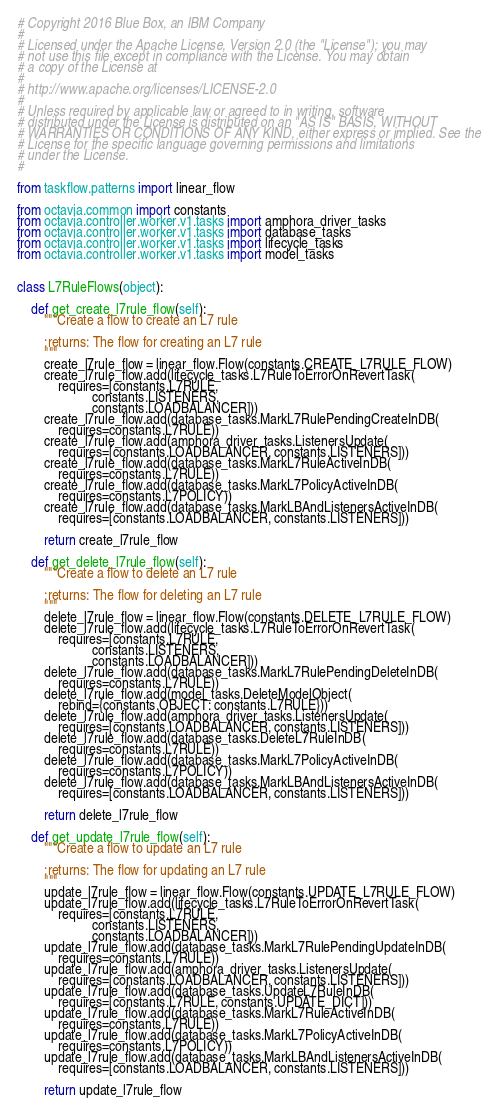Convert code to text. <code><loc_0><loc_0><loc_500><loc_500><_Python_># Copyright 2016 Blue Box, an IBM Company
#
# Licensed under the Apache License, Version 2.0 (the "License"); you may
# not use this file except in compliance with the License. You may obtain
# a copy of the License at
#
# http://www.apache.org/licenses/LICENSE-2.0
#
# Unless required by applicable law or agreed to in writing, software
# distributed under the License is distributed on an "AS IS" BASIS, WITHOUT
# WARRANTIES OR CONDITIONS OF ANY KIND, either express or implied. See the
# License for the specific language governing permissions and limitations
# under the License.
#

from taskflow.patterns import linear_flow

from octavia.common import constants
from octavia.controller.worker.v1.tasks import amphora_driver_tasks
from octavia.controller.worker.v1.tasks import database_tasks
from octavia.controller.worker.v1.tasks import lifecycle_tasks
from octavia.controller.worker.v1.tasks import model_tasks


class L7RuleFlows(object):

    def get_create_l7rule_flow(self):
        """Create a flow to create an L7 rule

        :returns: The flow for creating an L7 rule
        """
        create_l7rule_flow = linear_flow.Flow(constants.CREATE_L7RULE_FLOW)
        create_l7rule_flow.add(lifecycle_tasks.L7RuleToErrorOnRevertTask(
            requires=[constants.L7RULE,
                      constants.LISTENERS,
                      constants.LOADBALANCER]))
        create_l7rule_flow.add(database_tasks.MarkL7RulePendingCreateInDB(
            requires=constants.L7RULE))
        create_l7rule_flow.add(amphora_driver_tasks.ListenersUpdate(
            requires=[constants.LOADBALANCER, constants.LISTENERS]))
        create_l7rule_flow.add(database_tasks.MarkL7RuleActiveInDB(
            requires=constants.L7RULE))
        create_l7rule_flow.add(database_tasks.MarkL7PolicyActiveInDB(
            requires=constants.L7POLICY))
        create_l7rule_flow.add(database_tasks.MarkLBAndListenersActiveInDB(
            requires=[constants.LOADBALANCER, constants.LISTENERS]))

        return create_l7rule_flow

    def get_delete_l7rule_flow(self):
        """Create a flow to delete an L7 rule

        :returns: The flow for deleting an L7 rule
        """
        delete_l7rule_flow = linear_flow.Flow(constants.DELETE_L7RULE_FLOW)
        delete_l7rule_flow.add(lifecycle_tasks.L7RuleToErrorOnRevertTask(
            requires=[constants.L7RULE,
                      constants.LISTENERS,
                      constants.LOADBALANCER]))
        delete_l7rule_flow.add(database_tasks.MarkL7RulePendingDeleteInDB(
            requires=constants.L7RULE))
        delete_l7rule_flow.add(model_tasks.DeleteModelObject(
            rebind={constants.OBJECT: constants.L7RULE}))
        delete_l7rule_flow.add(amphora_driver_tasks.ListenersUpdate(
            requires=[constants.LOADBALANCER, constants.LISTENERS]))
        delete_l7rule_flow.add(database_tasks.DeleteL7RuleInDB(
            requires=constants.L7RULE))
        delete_l7rule_flow.add(database_tasks.MarkL7PolicyActiveInDB(
            requires=constants.L7POLICY))
        delete_l7rule_flow.add(database_tasks.MarkLBAndListenersActiveInDB(
            requires=[constants.LOADBALANCER, constants.LISTENERS]))

        return delete_l7rule_flow

    def get_update_l7rule_flow(self):
        """Create a flow to update an L7 rule

        :returns: The flow for updating an L7 rule
        """
        update_l7rule_flow = linear_flow.Flow(constants.UPDATE_L7RULE_FLOW)
        update_l7rule_flow.add(lifecycle_tasks.L7RuleToErrorOnRevertTask(
            requires=[constants.L7RULE,
                      constants.LISTENERS,
                      constants.LOADBALANCER]))
        update_l7rule_flow.add(database_tasks.MarkL7RulePendingUpdateInDB(
            requires=constants.L7RULE))
        update_l7rule_flow.add(amphora_driver_tasks.ListenersUpdate(
            requires=[constants.LOADBALANCER, constants.LISTENERS]))
        update_l7rule_flow.add(database_tasks.UpdateL7RuleInDB(
            requires=[constants.L7RULE, constants.UPDATE_DICT]))
        update_l7rule_flow.add(database_tasks.MarkL7RuleActiveInDB(
            requires=constants.L7RULE))
        update_l7rule_flow.add(database_tasks.MarkL7PolicyActiveInDB(
            requires=constants.L7POLICY))
        update_l7rule_flow.add(database_tasks.MarkLBAndListenersActiveInDB(
            requires=[constants.LOADBALANCER, constants.LISTENERS]))

        return update_l7rule_flow
</code> 